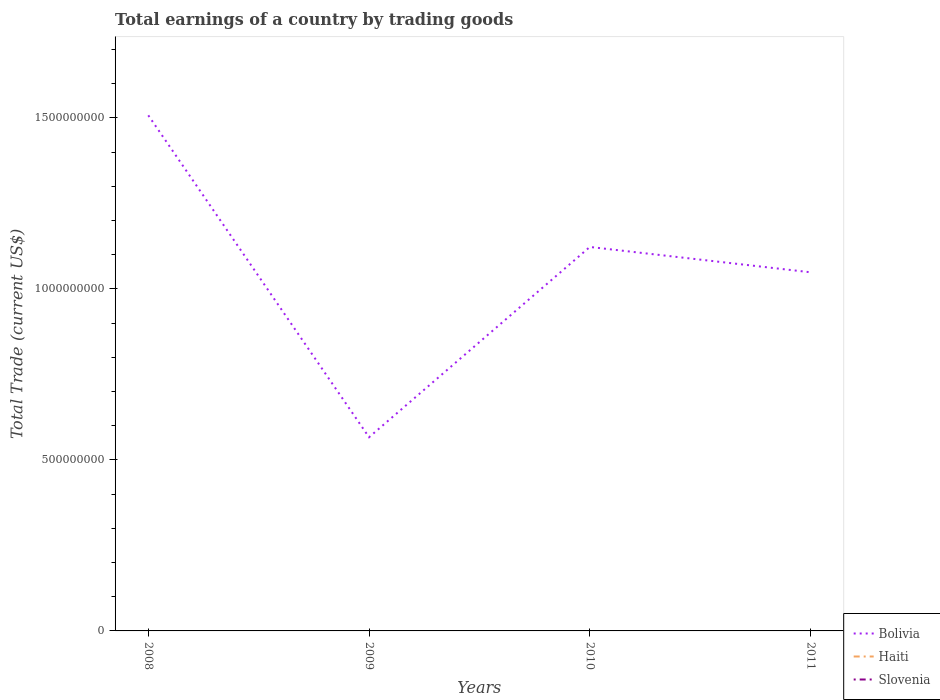Is the number of lines equal to the number of legend labels?
Your answer should be very brief. No. What is the total total earnings in Bolivia in the graph?
Make the answer very short. 4.59e+08. What is the difference between the highest and the second highest total earnings in Bolivia?
Provide a short and direct response. 9.41e+08. Is the total earnings in Bolivia strictly greater than the total earnings in Haiti over the years?
Your response must be concise. No. How many lines are there?
Keep it short and to the point. 1. Are the values on the major ticks of Y-axis written in scientific E-notation?
Offer a terse response. No. How many legend labels are there?
Offer a very short reply. 3. How are the legend labels stacked?
Provide a succinct answer. Vertical. What is the title of the graph?
Provide a short and direct response. Total earnings of a country by trading goods. Does "Bhutan" appear as one of the legend labels in the graph?
Ensure brevity in your answer.  No. What is the label or title of the Y-axis?
Give a very brief answer. Total Trade (current US$). What is the Total Trade (current US$) of Bolivia in 2008?
Give a very brief answer. 1.51e+09. What is the Total Trade (current US$) in Haiti in 2008?
Provide a succinct answer. 0. What is the Total Trade (current US$) of Bolivia in 2009?
Offer a very short reply. 5.66e+08. What is the Total Trade (current US$) of Haiti in 2009?
Keep it short and to the point. 0. What is the Total Trade (current US$) in Bolivia in 2010?
Ensure brevity in your answer.  1.12e+09. What is the Total Trade (current US$) of Haiti in 2010?
Provide a short and direct response. 0. What is the Total Trade (current US$) in Bolivia in 2011?
Provide a short and direct response. 1.05e+09. What is the Total Trade (current US$) in Slovenia in 2011?
Your answer should be compact. 0. Across all years, what is the maximum Total Trade (current US$) of Bolivia?
Offer a very short reply. 1.51e+09. Across all years, what is the minimum Total Trade (current US$) of Bolivia?
Provide a succinct answer. 5.66e+08. What is the total Total Trade (current US$) of Bolivia in the graph?
Your response must be concise. 4.24e+09. What is the total Total Trade (current US$) of Haiti in the graph?
Make the answer very short. 0. What is the total Total Trade (current US$) in Slovenia in the graph?
Offer a terse response. 0. What is the difference between the Total Trade (current US$) of Bolivia in 2008 and that in 2009?
Provide a succinct answer. 9.41e+08. What is the difference between the Total Trade (current US$) in Bolivia in 2008 and that in 2010?
Offer a terse response. 3.85e+08. What is the difference between the Total Trade (current US$) of Bolivia in 2008 and that in 2011?
Give a very brief answer. 4.59e+08. What is the difference between the Total Trade (current US$) of Bolivia in 2009 and that in 2010?
Offer a terse response. -5.56e+08. What is the difference between the Total Trade (current US$) of Bolivia in 2009 and that in 2011?
Offer a very short reply. -4.82e+08. What is the difference between the Total Trade (current US$) of Bolivia in 2010 and that in 2011?
Provide a succinct answer. 7.41e+07. What is the average Total Trade (current US$) in Bolivia per year?
Your answer should be compact. 1.06e+09. What is the ratio of the Total Trade (current US$) in Bolivia in 2008 to that in 2009?
Your answer should be very brief. 2.66. What is the ratio of the Total Trade (current US$) in Bolivia in 2008 to that in 2010?
Your response must be concise. 1.34. What is the ratio of the Total Trade (current US$) of Bolivia in 2008 to that in 2011?
Keep it short and to the point. 1.44. What is the ratio of the Total Trade (current US$) of Bolivia in 2009 to that in 2010?
Give a very brief answer. 0.5. What is the ratio of the Total Trade (current US$) of Bolivia in 2009 to that in 2011?
Your answer should be very brief. 0.54. What is the ratio of the Total Trade (current US$) of Bolivia in 2010 to that in 2011?
Provide a short and direct response. 1.07. What is the difference between the highest and the second highest Total Trade (current US$) in Bolivia?
Offer a terse response. 3.85e+08. What is the difference between the highest and the lowest Total Trade (current US$) of Bolivia?
Give a very brief answer. 9.41e+08. 